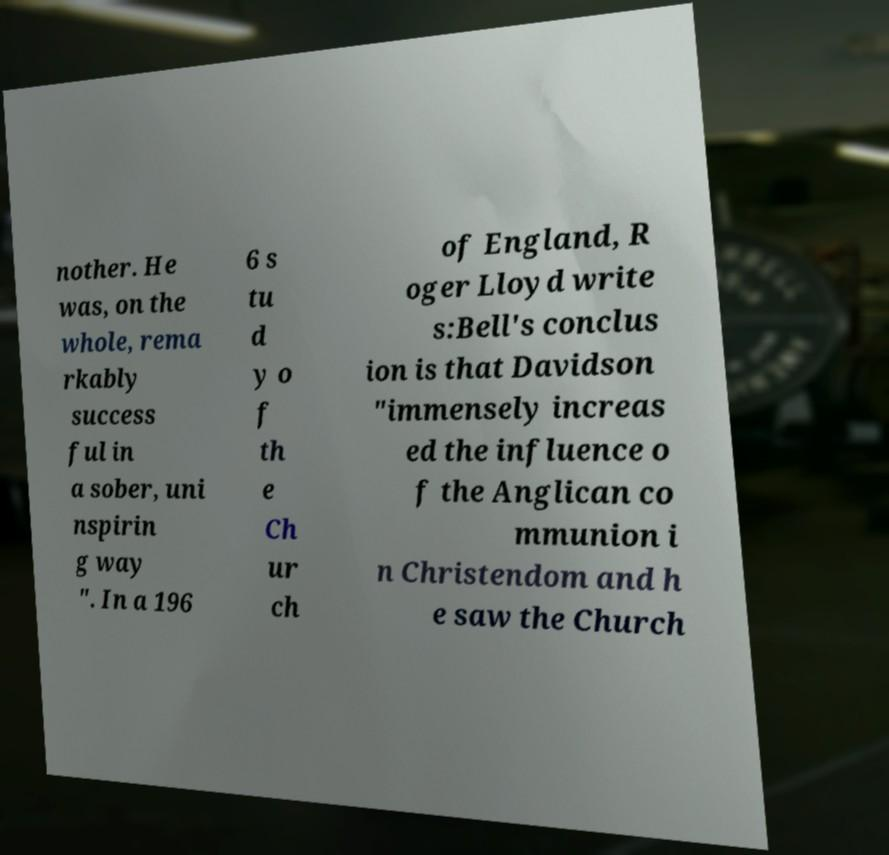For documentation purposes, I need the text within this image transcribed. Could you provide that? nother. He was, on the whole, rema rkably success ful in a sober, uni nspirin g way ". In a 196 6 s tu d y o f th e Ch ur ch of England, R oger Lloyd write s:Bell's conclus ion is that Davidson "immensely increas ed the influence o f the Anglican co mmunion i n Christendom and h e saw the Church 